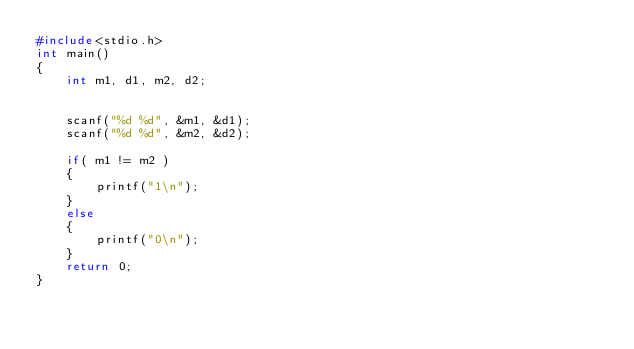Convert code to text. <code><loc_0><loc_0><loc_500><loc_500><_C_>#include<stdio.h>
int main()
{
    int m1, d1, m2, d2;


    scanf("%d %d", &m1, &d1);
    scanf("%d %d", &m2, &d2);
    
    if( m1 != m2 )
    {
    	printf("1\n");
    }
    else
    {
    	printf("0\n");
    }
    return 0;
}</code> 